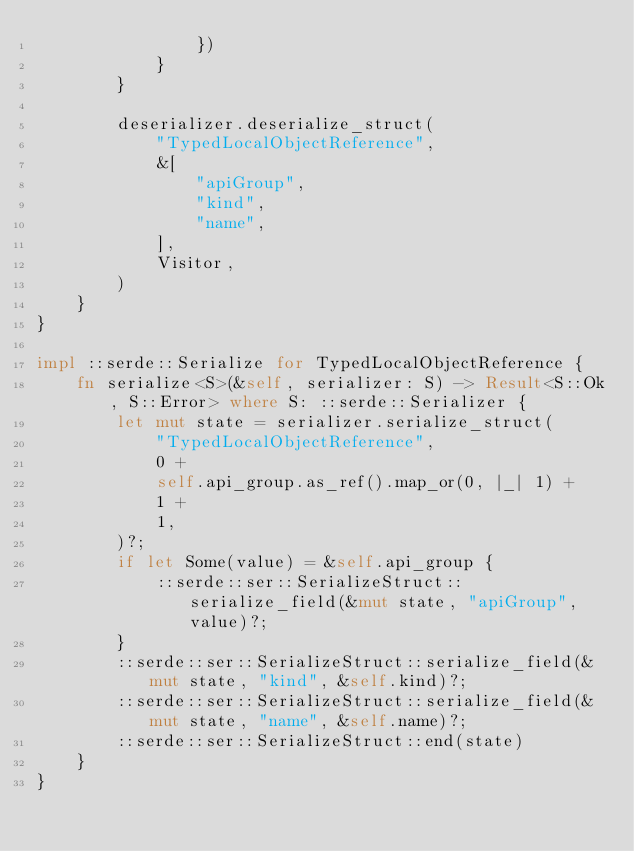Convert code to text. <code><loc_0><loc_0><loc_500><loc_500><_Rust_>                })
            }
        }

        deserializer.deserialize_struct(
            "TypedLocalObjectReference",
            &[
                "apiGroup",
                "kind",
                "name",
            ],
            Visitor,
        )
    }
}

impl ::serde::Serialize for TypedLocalObjectReference {
    fn serialize<S>(&self, serializer: S) -> Result<S::Ok, S::Error> where S: ::serde::Serializer {
        let mut state = serializer.serialize_struct(
            "TypedLocalObjectReference",
            0 +
            self.api_group.as_ref().map_or(0, |_| 1) +
            1 +
            1,
        )?;
        if let Some(value) = &self.api_group {
            ::serde::ser::SerializeStruct::serialize_field(&mut state, "apiGroup", value)?;
        }
        ::serde::ser::SerializeStruct::serialize_field(&mut state, "kind", &self.kind)?;
        ::serde::ser::SerializeStruct::serialize_field(&mut state, "name", &self.name)?;
        ::serde::ser::SerializeStruct::end(state)
    }
}
</code> 